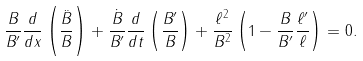Convert formula to latex. <formula><loc_0><loc_0><loc_500><loc_500>\frac { B } { B ^ { \prime } } \frac { d } { d x } \left ( \frac { \ddot { B } } { B } \right ) + \frac { \dot { B } } { B ^ { \prime } } \frac { d } { d t } \left ( \frac { B ^ { \prime } } { B } \right ) + \frac { \ell ^ { 2 } } { B ^ { 2 } } \left ( 1 - \frac { B } { B ^ { \prime } } \frac { \ell ^ { \prime } } { \ell } \right ) = 0 .</formula> 